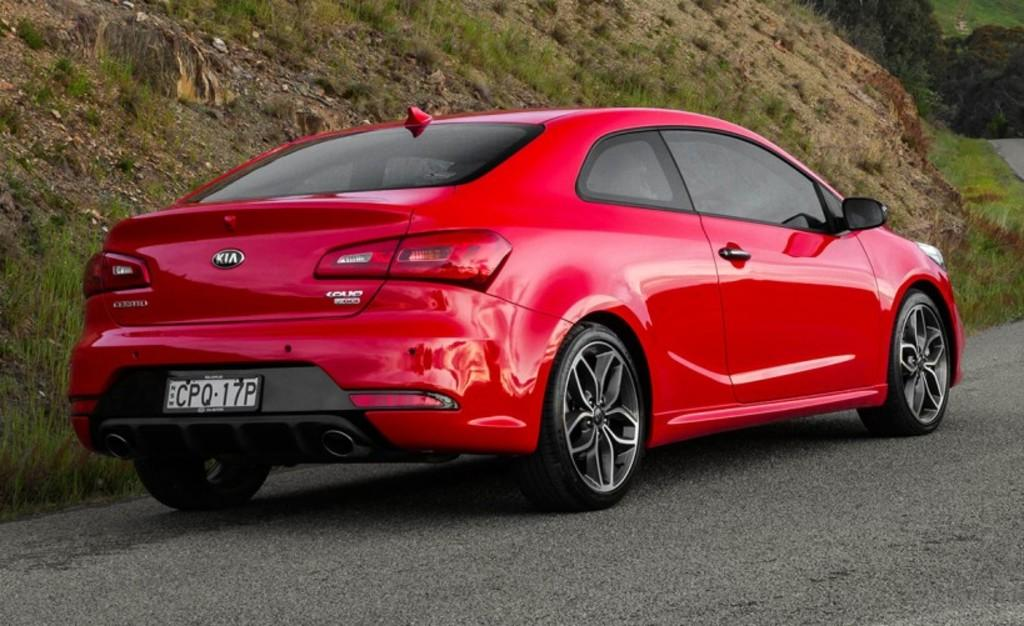What color is the car in the image? The car in the image is red. Where is the car located in the image? The car is on the road in the image. What can be seen in the background of the image? There is a mountain and trees in the background of the image. How does the car support the quiver in the image? There is no quiver present in the image, and the car is not supporting anything. 